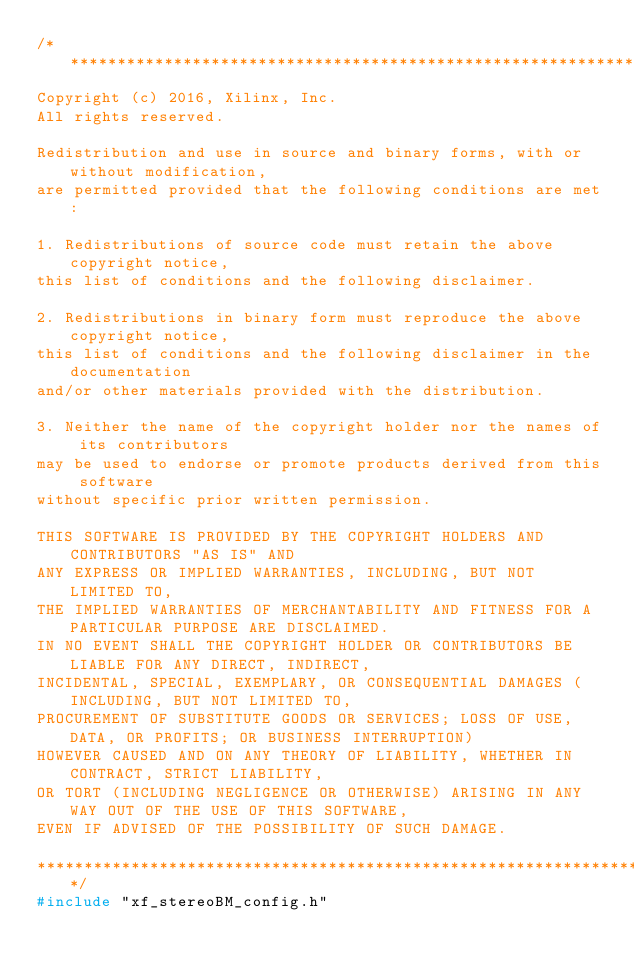<code> <loc_0><loc_0><loc_500><loc_500><_C++_>/***************************************************************************
Copyright (c) 2016, Xilinx, Inc.
All rights reserved.

Redistribution and use in source and binary forms, with or without modification, 
are permitted provided that the following conditions are met:

1. Redistributions of source code must retain the above copyright notice, 
this list of conditions and the following disclaimer.

2. Redistributions in binary form must reproduce the above copyright notice, 
this list of conditions and the following disclaimer in the documentation 
and/or other materials provided with the distribution.

3. Neither the name of the copyright holder nor the names of its contributors 
may be used to endorse or promote products derived from this software 
without specific prior written permission.

THIS SOFTWARE IS PROVIDED BY THE COPYRIGHT HOLDERS AND CONTRIBUTORS "AS IS" AND 
ANY EXPRESS OR IMPLIED WARRANTIES, INCLUDING, BUT NOT LIMITED TO, 
THE IMPLIED WARRANTIES OF MERCHANTABILITY AND FITNESS FOR A PARTICULAR PURPOSE ARE DISCLAIMED. 
IN NO EVENT SHALL THE COPYRIGHT HOLDER OR CONTRIBUTORS BE LIABLE FOR ANY DIRECT, INDIRECT, 
INCIDENTAL, SPECIAL, EXEMPLARY, OR CONSEQUENTIAL DAMAGES (INCLUDING, BUT NOT LIMITED TO, 
PROCUREMENT OF SUBSTITUTE GOODS OR SERVICES; LOSS OF USE, DATA, OR PROFITS; OR BUSINESS INTERRUPTION) 
HOWEVER CAUSED AND ON ANY THEORY OF LIABILITY, WHETHER IN CONTRACT, STRICT LIABILITY, 
OR TORT (INCLUDING NEGLIGENCE OR OTHERWISE) ARISING IN ANY WAY OUT OF THE USE OF THIS SOFTWARE, 
EVEN IF ADVISED OF THE POSSIBILITY OF SUCH DAMAGE.

***************************************************************************/
#include "xf_stereoBM_config.h"
</code> 